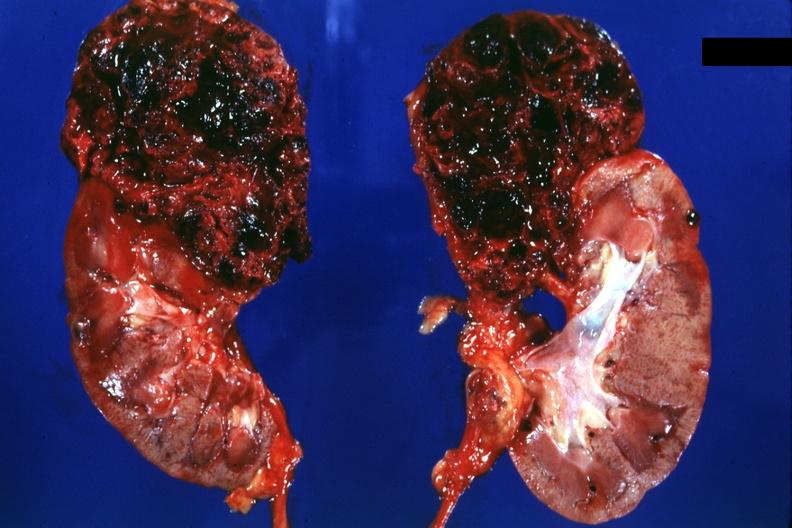what is present?
Answer the question using a single word or phrase. Renal cell carcinoma 